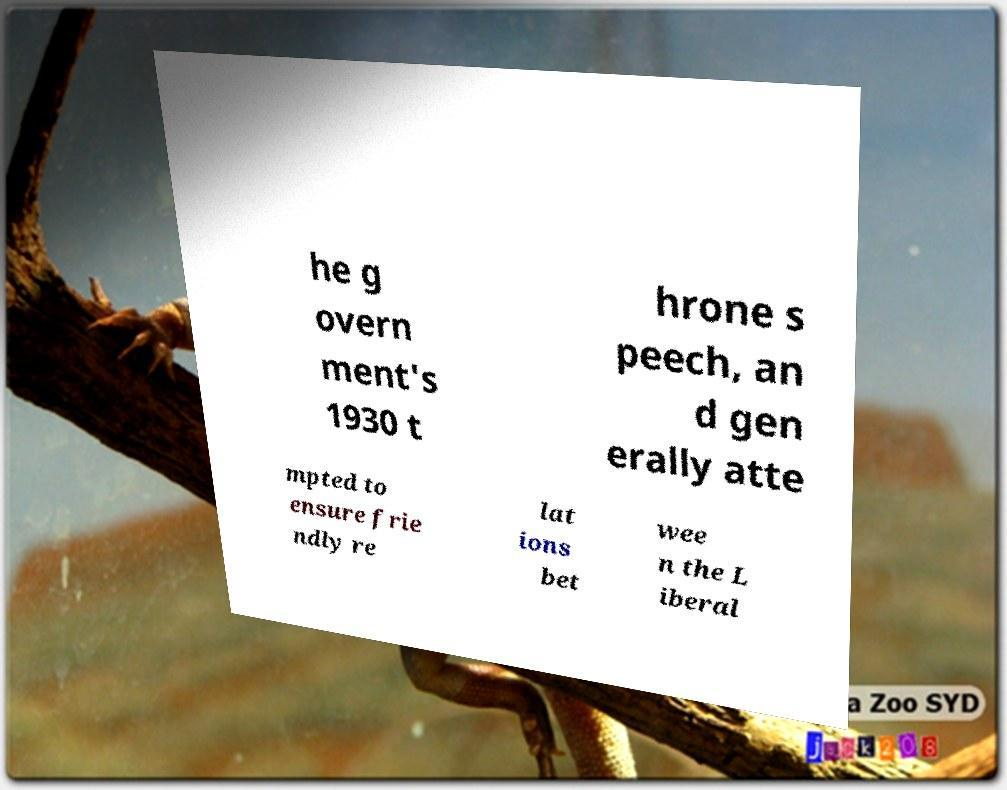There's text embedded in this image that I need extracted. Can you transcribe it verbatim? he g overn ment's 1930 t hrone s peech, an d gen erally atte mpted to ensure frie ndly re lat ions bet wee n the L iberal 